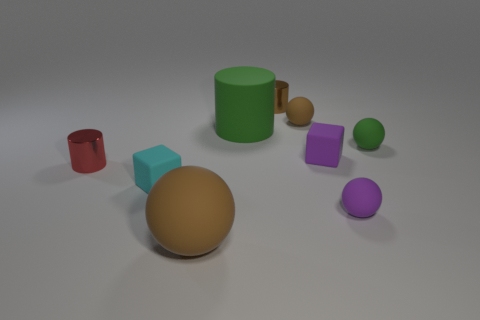Subtract all small matte balls. How many balls are left? 1 Subtract all cyan cubes. How many cubes are left? 1 Subtract 2 blocks. How many blocks are left? 0 Subtract all metallic things. Subtract all tiny brown cylinders. How many objects are left? 6 Add 6 big brown matte things. How many big brown matte things are left? 7 Add 4 green rubber cylinders. How many green rubber cylinders exist? 5 Subtract 0 gray cubes. How many objects are left? 9 Subtract all cubes. How many objects are left? 7 Subtract all blue balls. Subtract all green cylinders. How many balls are left? 4 Subtract all red cubes. How many brown balls are left? 2 